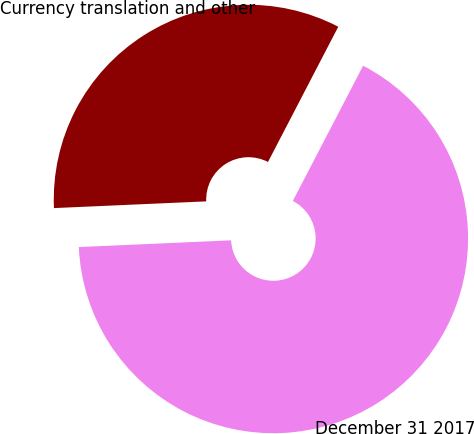Convert chart. <chart><loc_0><loc_0><loc_500><loc_500><pie_chart><fcel>Currency translation and other<fcel>December 31 2017<nl><fcel>33.33%<fcel>66.67%<nl></chart> 